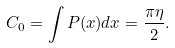<formula> <loc_0><loc_0><loc_500><loc_500>C _ { 0 } = \int P ( x ) d x = \frac { \pi \eta } { 2 } .</formula> 